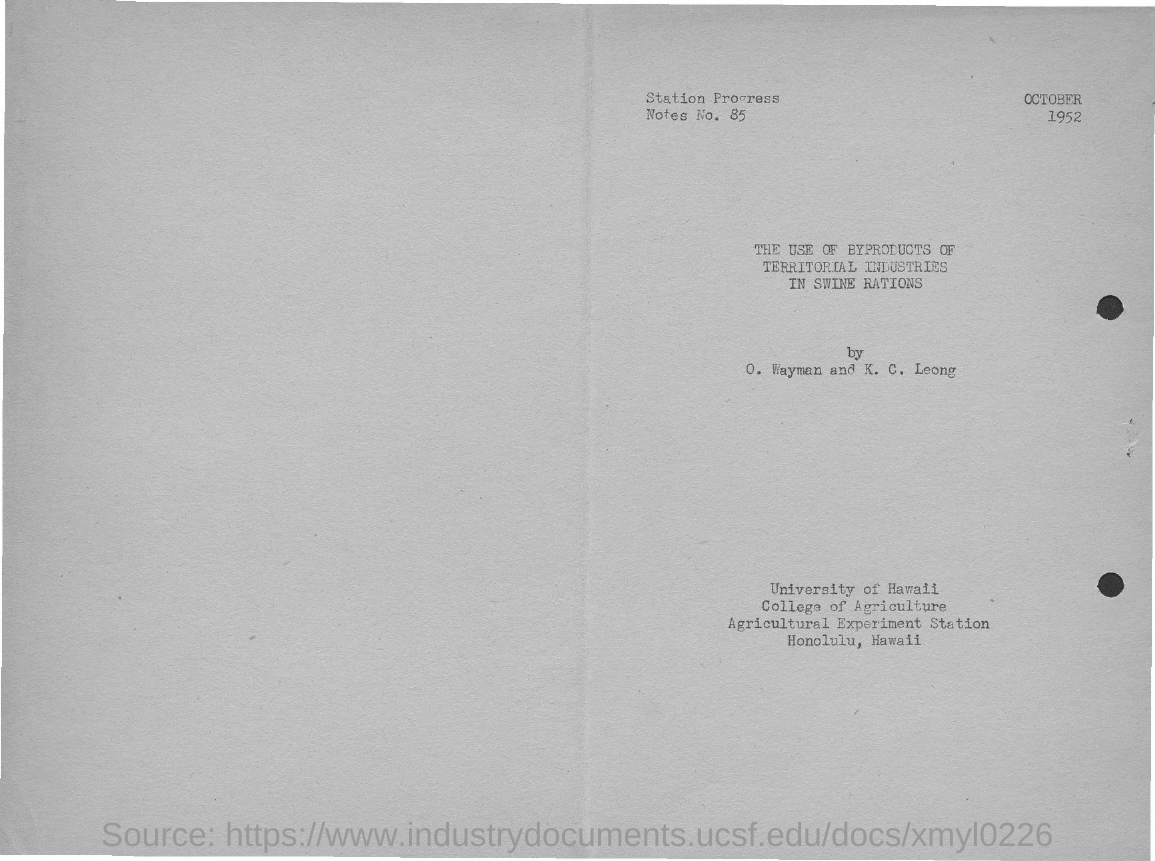List a handful of essential elements in this visual. The document mentions the date of October 1952. There are 85 station progress notes. 